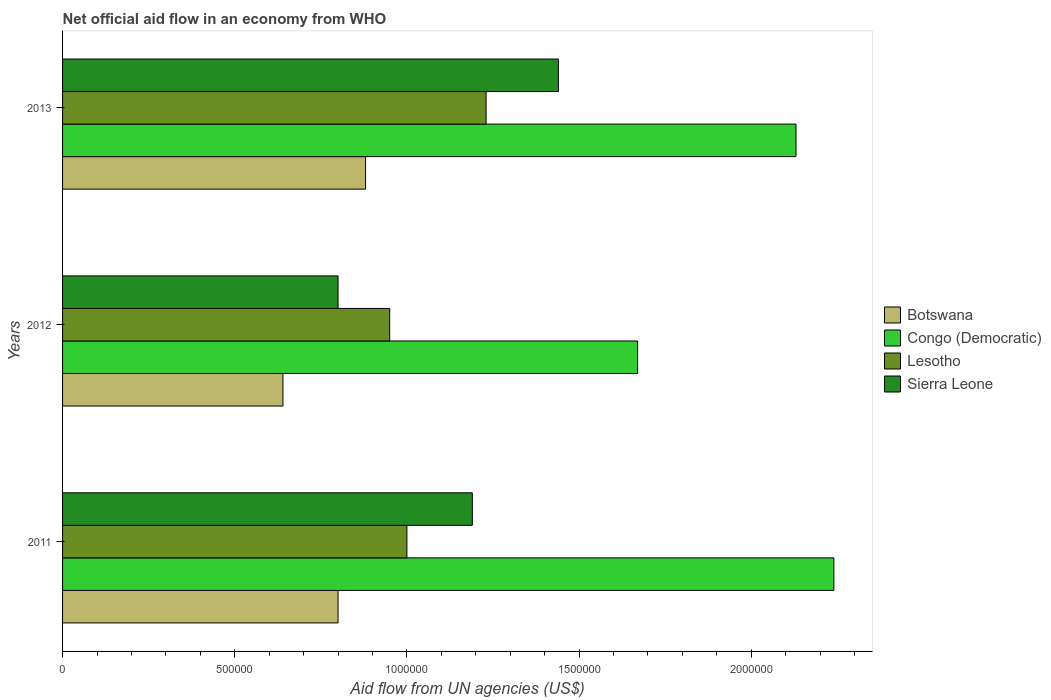Are the number of bars per tick equal to the number of legend labels?
Give a very brief answer. Yes. How many bars are there on the 2nd tick from the top?
Your answer should be very brief. 4. How many bars are there on the 3rd tick from the bottom?
Keep it short and to the point. 4. What is the label of the 1st group of bars from the top?
Provide a short and direct response. 2013. What is the net official aid flow in Lesotho in 2012?
Provide a short and direct response. 9.50e+05. Across all years, what is the maximum net official aid flow in Lesotho?
Offer a terse response. 1.23e+06. Across all years, what is the minimum net official aid flow in Botswana?
Your answer should be compact. 6.40e+05. In which year was the net official aid flow in Sierra Leone minimum?
Offer a terse response. 2012. What is the total net official aid flow in Congo (Democratic) in the graph?
Provide a short and direct response. 6.04e+06. What is the difference between the net official aid flow in Congo (Democratic) in 2011 and that in 2012?
Ensure brevity in your answer.  5.70e+05. What is the difference between the net official aid flow in Sierra Leone in 2013 and the net official aid flow in Congo (Democratic) in 2012?
Provide a short and direct response. -2.30e+05. What is the average net official aid flow in Lesotho per year?
Provide a succinct answer. 1.06e+06. In the year 2012, what is the difference between the net official aid flow in Lesotho and net official aid flow in Congo (Democratic)?
Keep it short and to the point. -7.20e+05. What is the ratio of the net official aid flow in Lesotho in 2012 to that in 2013?
Keep it short and to the point. 0.77. What is the difference between the highest and the second highest net official aid flow in Botswana?
Make the answer very short. 8.00e+04. What is the difference between the highest and the lowest net official aid flow in Congo (Democratic)?
Ensure brevity in your answer.  5.70e+05. In how many years, is the net official aid flow in Congo (Democratic) greater than the average net official aid flow in Congo (Democratic) taken over all years?
Offer a very short reply. 2. Is the sum of the net official aid flow in Congo (Democratic) in 2011 and 2012 greater than the maximum net official aid flow in Sierra Leone across all years?
Offer a very short reply. Yes. Is it the case that in every year, the sum of the net official aid flow in Botswana and net official aid flow in Congo (Democratic) is greater than the sum of net official aid flow in Sierra Leone and net official aid flow in Lesotho?
Your answer should be very brief. No. What does the 1st bar from the top in 2013 represents?
Provide a succinct answer. Sierra Leone. What does the 1st bar from the bottom in 2013 represents?
Give a very brief answer. Botswana. How many bars are there?
Provide a succinct answer. 12. Are all the bars in the graph horizontal?
Give a very brief answer. Yes. Does the graph contain any zero values?
Give a very brief answer. No. Does the graph contain grids?
Give a very brief answer. No. How many legend labels are there?
Offer a terse response. 4. What is the title of the graph?
Your response must be concise. Net official aid flow in an economy from WHO. What is the label or title of the X-axis?
Keep it short and to the point. Aid flow from UN agencies (US$). What is the Aid flow from UN agencies (US$) in Botswana in 2011?
Keep it short and to the point. 8.00e+05. What is the Aid flow from UN agencies (US$) in Congo (Democratic) in 2011?
Keep it short and to the point. 2.24e+06. What is the Aid flow from UN agencies (US$) in Sierra Leone in 2011?
Offer a very short reply. 1.19e+06. What is the Aid flow from UN agencies (US$) of Botswana in 2012?
Offer a very short reply. 6.40e+05. What is the Aid flow from UN agencies (US$) of Congo (Democratic) in 2012?
Offer a very short reply. 1.67e+06. What is the Aid flow from UN agencies (US$) in Lesotho in 2012?
Your answer should be compact. 9.50e+05. What is the Aid flow from UN agencies (US$) in Sierra Leone in 2012?
Offer a terse response. 8.00e+05. What is the Aid flow from UN agencies (US$) of Botswana in 2013?
Provide a succinct answer. 8.80e+05. What is the Aid flow from UN agencies (US$) in Congo (Democratic) in 2013?
Provide a short and direct response. 2.13e+06. What is the Aid flow from UN agencies (US$) in Lesotho in 2013?
Offer a very short reply. 1.23e+06. What is the Aid flow from UN agencies (US$) of Sierra Leone in 2013?
Make the answer very short. 1.44e+06. Across all years, what is the maximum Aid flow from UN agencies (US$) in Botswana?
Give a very brief answer. 8.80e+05. Across all years, what is the maximum Aid flow from UN agencies (US$) in Congo (Democratic)?
Your response must be concise. 2.24e+06. Across all years, what is the maximum Aid flow from UN agencies (US$) in Lesotho?
Keep it short and to the point. 1.23e+06. Across all years, what is the maximum Aid flow from UN agencies (US$) of Sierra Leone?
Your response must be concise. 1.44e+06. Across all years, what is the minimum Aid flow from UN agencies (US$) of Botswana?
Provide a succinct answer. 6.40e+05. Across all years, what is the minimum Aid flow from UN agencies (US$) in Congo (Democratic)?
Give a very brief answer. 1.67e+06. Across all years, what is the minimum Aid flow from UN agencies (US$) in Lesotho?
Your answer should be very brief. 9.50e+05. What is the total Aid flow from UN agencies (US$) in Botswana in the graph?
Offer a terse response. 2.32e+06. What is the total Aid flow from UN agencies (US$) in Congo (Democratic) in the graph?
Your response must be concise. 6.04e+06. What is the total Aid flow from UN agencies (US$) in Lesotho in the graph?
Ensure brevity in your answer.  3.18e+06. What is the total Aid flow from UN agencies (US$) in Sierra Leone in the graph?
Your answer should be compact. 3.43e+06. What is the difference between the Aid flow from UN agencies (US$) of Botswana in 2011 and that in 2012?
Your answer should be very brief. 1.60e+05. What is the difference between the Aid flow from UN agencies (US$) of Congo (Democratic) in 2011 and that in 2012?
Provide a succinct answer. 5.70e+05. What is the difference between the Aid flow from UN agencies (US$) in Sierra Leone in 2011 and that in 2012?
Keep it short and to the point. 3.90e+05. What is the difference between the Aid flow from UN agencies (US$) of Congo (Democratic) in 2011 and that in 2013?
Offer a terse response. 1.10e+05. What is the difference between the Aid flow from UN agencies (US$) of Lesotho in 2011 and that in 2013?
Offer a terse response. -2.30e+05. What is the difference between the Aid flow from UN agencies (US$) of Sierra Leone in 2011 and that in 2013?
Provide a succinct answer. -2.50e+05. What is the difference between the Aid flow from UN agencies (US$) of Botswana in 2012 and that in 2013?
Your answer should be compact. -2.40e+05. What is the difference between the Aid flow from UN agencies (US$) in Congo (Democratic) in 2012 and that in 2013?
Your answer should be very brief. -4.60e+05. What is the difference between the Aid flow from UN agencies (US$) of Lesotho in 2012 and that in 2013?
Offer a very short reply. -2.80e+05. What is the difference between the Aid flow from UN agencies (US$) of Sierra Leone in 2012 and that in 2013?
Make the answer very short. -6.40e+05. What is the difference between the Aid flow from UN agencies (US$) of Botswana in 2011 and the Aid flow from UN agencies (US$) of Congo (Democratic) in 2012?
Offer a very short reply. -8.70e+05. What is the difference between the Aid flow from UN agencies (US$) of Botswana in 2011 and the Aid flow from UN agencies (US$) of Sierra Leone in 2012?
Provide a succinct answer. 0. What is the difference between the Aid flow from UN agencies (US$) of Congo (Democratic) in 2011 and the Aid flow from UN agencies (US$) of Lesotho in 2012?
Your response must be concise. 1.29e+06. What is the difference between the Aid flow from UN agencies (US$) of Congo (Democratic) in 2011 and the Aid flow from UN agencies (US$) of Sierra Leone in 2012?
Provide a succinct answer. 1.44e+06. What is the difference between the Aid flow from UN agencies (US$) of Lesotho in 2011 and the Aid flow from UN agencies (US$) of Sierra Leone in 2012?
Keep it short and to the point. 2.00e+05. What is the difference between the Aid flow from UN agencies (US$) in Botswana in 2011 and the Aid flow from UN agencies (US$) in Congo (Democratic) in 2013?
Keep it short and to the point. -1.33e+06. What is the difference between the Aid flow from UN agencies (US$) of Botswana in 2011 and the Aid flow from UN agencies (US$) of Lesotho in 2013?
Offer a terse response. -4.30e+05. What is the difference between the Aid flow from UN agencies (US$) in Botswana in 2011 and the Aid flow from UN agencies (US$) in Sierra Leone in 2013?
Keep it short and to the point. -6.40e+05. What is the difference between the Aid flow from UN agencies (US$) of Congo (Democratic) in 2011 and the Aid flow from UN agencies (US$) of Lesotho in 2013?
Your answer should be compact. 1.01e+06. What is the difference between the Aid flow from UN agencies (US$) in Lesotho in 2011 and the Aid flow from UN agencies (US$) in Sierra Leone in 2013?
Keep it short and to the point. -4.40e+05. What is the difference between the Aid flow from UN agencies (US$) in Botswana in 2012 and the Aid flow from UN agencies (US$) in Congo (Democratic) in 2013?
Provide a succinct answer. -1.49e+06. What is the difference between the Aid flow from UN agencies (US$) in Botswana in 2012 and the Aid flow from UN agencies (US$) in Lesotho in 2013?
Provide a short and direct response. -5.90e+05. What is the difference between the Aid flow from UN agencies (US$) in Botswana in 2012 and the Aid flow from UN agencies (US$) in Sierra Leone in 2013?
Offer a terse response. -8.00e+05. What is the difference between the Aid flow from UN agencies (US$) in Congo (Democratic) in 2012 and the Aid flow from UN agencies (US$) in Lesotho in 2013?
Give a very brief answer. 4.40e+05. What is the difference between the Aid flow from UN agencies (US$) in Lesotho in 2012 and the Aid flow from UN agencies (US$) in Sierra Leone in 2013?
Keep it short and to the point. -4.90e+05. What is the average Aid flow from UN agencies (US$) in Botswana per year?
Your answer should be very brief. 7.73e+05. What is the average Aid flow from UN agencies (US$) in Congo (Democratic) per year?
Provide a short and direct response. 2.01e+06. What is the average Aid flow from UN agencies (US$) in Lesotho per year?
Your answer should be compact. 1.06e+06. What is the average Aid flow from UN agencies (US$) in Sierra Leone per year?
Ensure brevity in your answer.  1.14e+06. In the year 2011, what is the difference between the Aid flow from UN agencies (US$) in Botswana and Aid flow from UN agencies (US$) in Congo (Democratic)?
Make the answer very short. -1.44e+06. In the year 2011, what is the difference between the Aid flow from UN agencies (US$) of Botswana and Aid flow from UN agencies (US$) of Sierra Leone?
Keep it short and to the point. -3.90e+05. In the year 2011, what is the difference between the Aid flow from UN agencies (US$) in Congo (Democratic) and Aid flow from UN agencies (US$) in Lesotho?
Your answer should be very brief. 1.24e+06. In the year 2011, what is the difference between the Aid flow from UN agencies (US$) of Congo (Democratic) and Aid flow from UN agencies (US$) of Sierra Leone?
Provide a succinct answer. 1.05e+06. In the year 2012, what is the difference between the Aid flow from UN agencies (US$) of Botswana and Aid flow from UN agencies (US$) of Congo (Democratic)?
Provide a short and direct response. -1.03e+06. In the year 2012, what is the difference between the Aid flow from UN agencies (US$) of Botswana and Aid flow from UN agencies (US$) of Lesotho?
Offer a terse response. -3.10e+05. In the year 2012, what is the difference between the Aid flow from UN agencies (US$) in Botswana and Aid flow from UN agencies (US$) in Sierra Leone?
Provide a succinct answer. -1.60e+05. In the year 2012, what is the difference between the Aid flow from UN agencies (US$) of Congo (Democratic) and Aid flow from UN agencies (US$) of Lesotho?
Provide a short and direct response. 7.20e+05. In the year 2012, what is the difference between the Aid flow from UN agencies (US$) of Congo (Democratic) and Aid flow from UN agencies (US$) of Sierra Leone?
Provide a short and direct response. 8.70e+05. In the year 2012, what is the difference between the Aid flow from UN agencies (US$) of Lesotho and Aid flow from UN agencies (US$) of Sierra Leone?
Your answer should be compact. 1.50e+05. In the year 2013, what is the difference between the Aid flow from UN agencies (US$) of Botswana and Aid flow from UN agencies (US$) of Congo (Democratic)?
Make the answer very short. -1.25e+06. In the year 2013, what is the difference between the Aid flow from UN agencies (US$) of Botswana and Aid flow from UN agencies (US$) of Lesotho?
Your answer should be compact. -3.50e+05. In the year 2013, what is the difference between the Aid flow from UN agencies (US$) in Botswana and Aid flow from UN agencies (US$) in Sierra Leone?
Your response must be concise. -5.60e+05. In the year 2013, what is the difference between the Aid flow from UN agencies (US$) of Congo (Democratic) and Aid flow from UN agencies (US$) of Sierra Leone?
Your answer should be very brief. 6.90e+05. In the year 2013, what is the difference between the Aid flow from UN agencies (US$) of Lesotho and Aid flow from UN agencies (US$) of Sierra Leone?
Ensure brevity in your answer.  -2.10e+05. What is the ratio of the Aid flow from UN agencies (US$) in Congo (Democratic) in 2011 to that in 2012?
Your response must be concise. 1.34. What is the ratio of the Aid flow from UN agencies (US$) of Lesotho in 2011 to that in 2012?
Your answer should be very brief. 1.05. What is the ratio of the Aid flow from UN agencies (US$) in Sierra Leone in 2011 to that in 2012?
Make the answer very short. 1.49. What is the ratio of the Aid flow from UN agencies (US$) in Congo (Democratic) in 2011 to that in 2013?
Your answer should be compact. 1.05. What is the ratio of the Aid flow from UN agencies (US$) of Lesotho in 2011 to that in 2013?
Offer a terse response. 0.81. What is the ratio of the Aid flow from UN agencies (US$) of Sierra Leone in 2011 to that in 2013?
Keep it short and to the point. 0.83. What is the ratio of the Aid flow from UN agencies (US$) of Botswana in 2012 to that in 2013?
Your answer should be very brief. 0.73. What is the ratio of the Aid flow from UN agencies (US$) in Congo (Democratic) in 2012 to that in 2013?
Make the answer very short. 0.78. What is the ratio of the Aid flow from UN agencies (US$) in Lesotho in 2012 to that in 2013?
Make the answer very short. 0.77. What is the ratio of the Aid flow from UN agencies (US$) in Sierra Leone in 2012 to that in 2013?
Ensure brevity in your answer.  0.56. What is the difference between the highest and the second highest Aid flow from UN agencies (US$) of Lesotho?
Provide a succinct answer. 2.30e+05. What is the difference between the highest and the lowest Aid flow from UN agencies (US$) in Botswana?
Your answer should be very brief. 2.40e+05. What is the difference between the highest and the lowest Aid flow from UN agencies (US$) in Congo (Democratic)?
Offer a very short reply. 5.70e+05. What is the difference between the highest and the lowest Aid flow from UN agencies (US$) of Lesotho?
Your response must be concise. 2.80e+05. What is the difference between the highest and the lowest Aid flow from UN agencies (US$) of Sierra Leone?
Provide a succinct answer. 6.40e+05. 